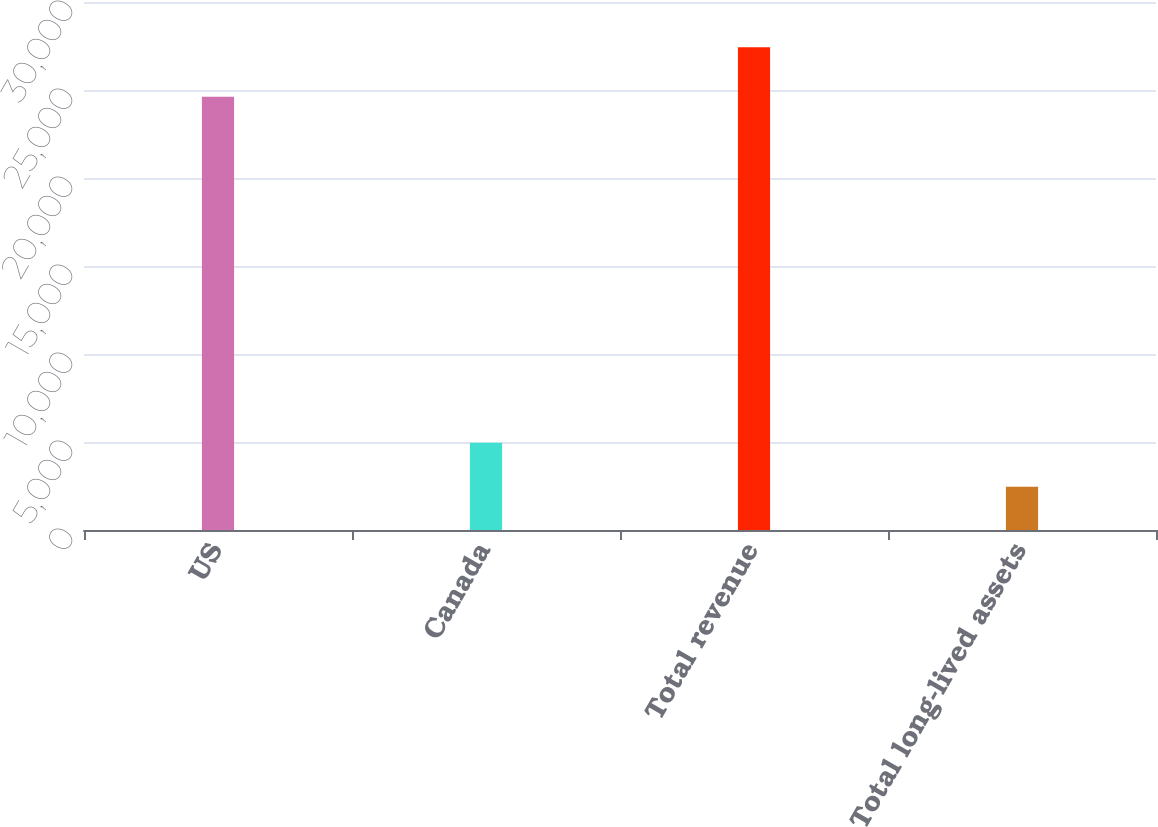Convert chart to OTSL. <chart><loc_0><loc_0><loc_500><loc_500><bar_chart><fcel>US<fcel>Canada<fcel>Total revenue<fcel>Total long-lived assets<nl><fcel>24616<fcel>4960.9<fcel>27433<fcel>2464<nl></chart> 